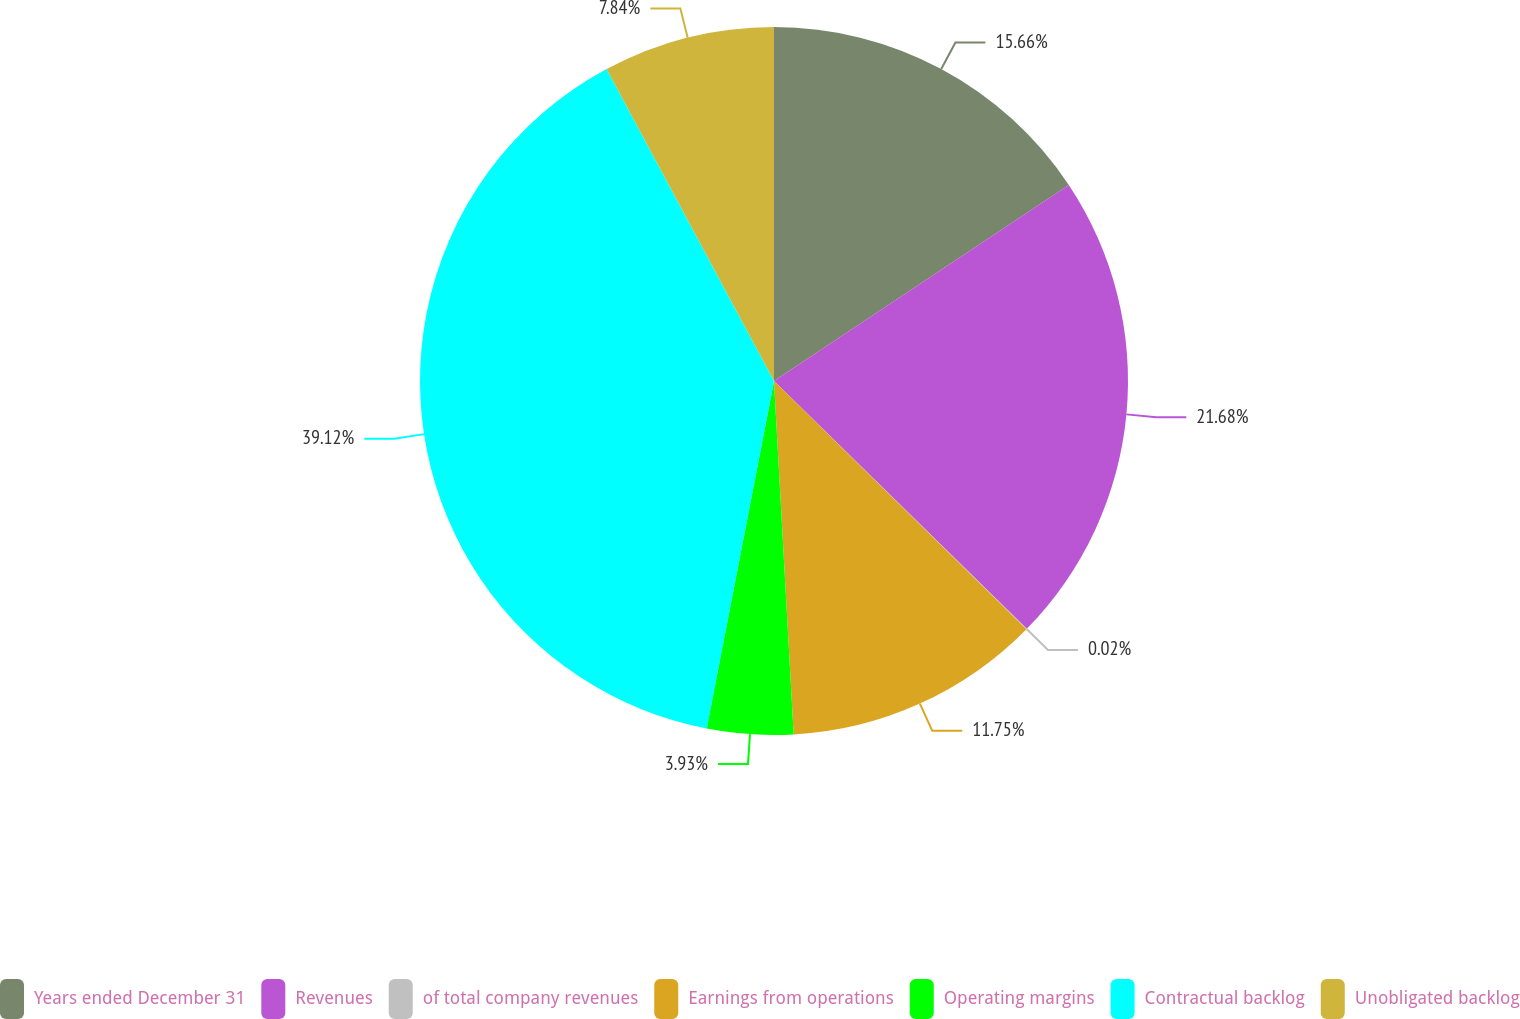<chart> <loc_0><loc_0><loc_500><loc_500><pie_chart><fcel>Years ended December 31<fcel>Revenues<fcel>of total company revenues<fcel>Earnings from operations<fcel>Operating margins<fcel>Contractual backlog<fcel>Unobligated backlog<nl><fcel>15.66%<fcel>21.68%<fcel>0.02%<fcel>11.75%<fcel>3.93%<fcel>39.11%<fcel>7.84%<nl></chart> 